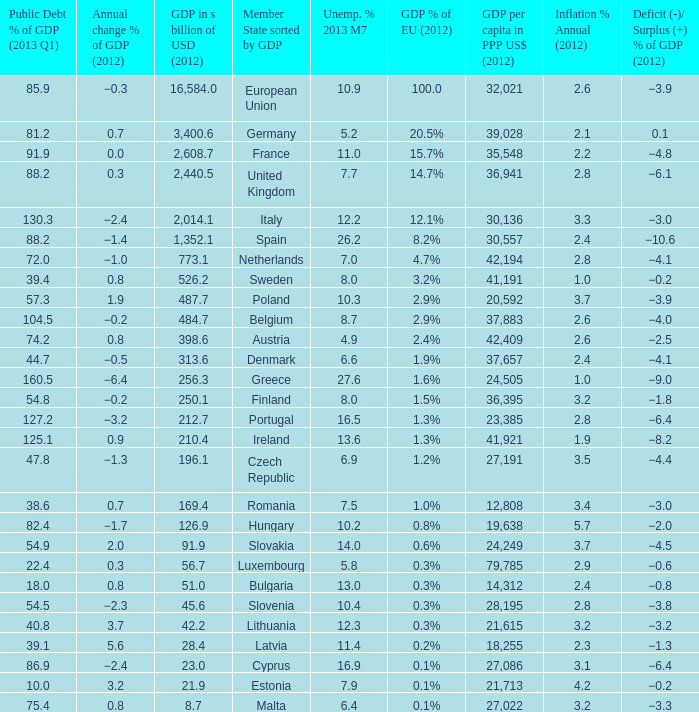9%? 2.6. 